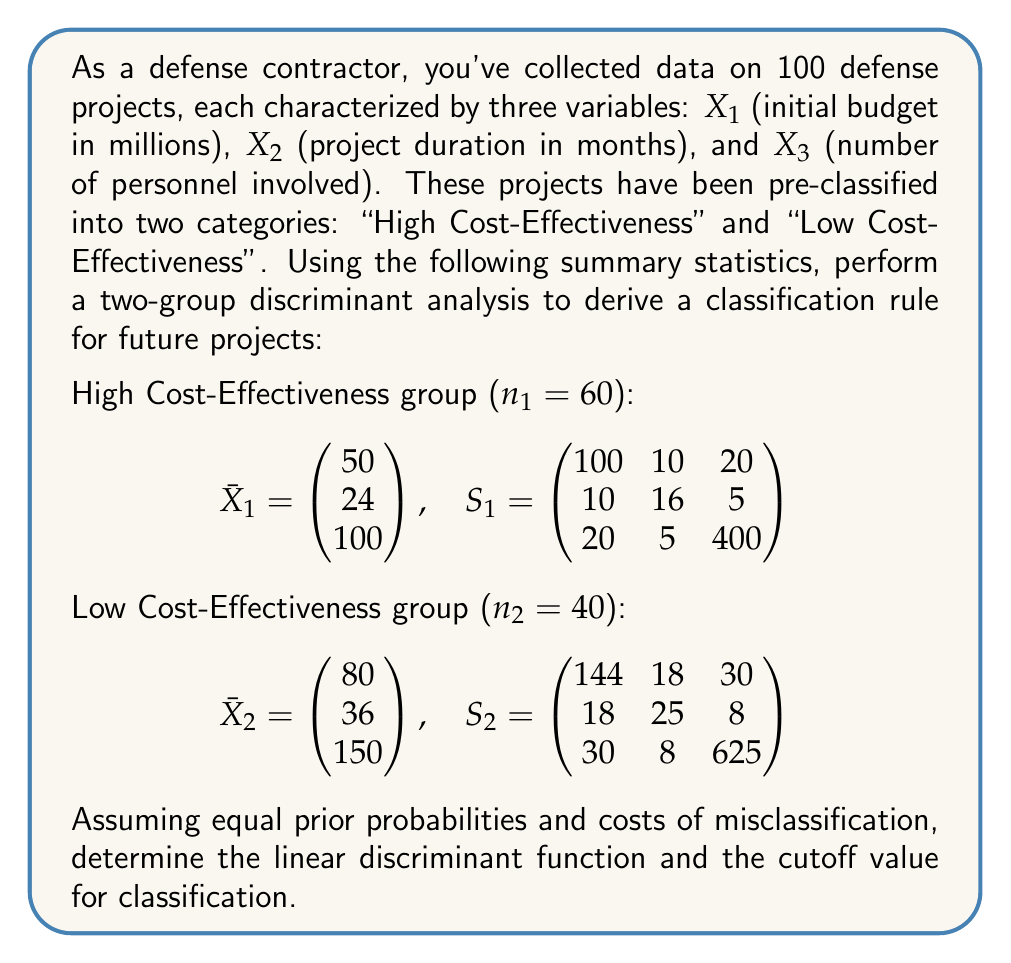Help me with this question. To perform a two-group discriminant analysis and derive a classification rule, we'll follow these steps:

1) Calculate the pooled covariance matrix:
   $$S_p = \frac{(n_1-1)S_1 + (n_2-1)S_2}{n_1+n_2-2}$$

   $$S_p = \frac{59\begin{pmatrix} 100 & 10 & 20 \\ 10 & 16 & 5 \\ 20 & 5 & 400 \end{pmatrix} + 39\begin{pmatrix} 144 & 18 & 30 \\ 18 & 25 & 8 \\ 30 & 8 & 625 \end{pmatrix}}{98}$$

   $$S_p = \begin{pmatrix} 117.8 & 13.2 & 24.0 \\ 13.2 & 19.6 & 6.2 \\ 24.0 & 6.2 & 490.3 \end{pmatrix}$$

2) Calculate the inverse of the pooled covariance matrix:
   $$S_p^{-1} = \begin{pmatrix} 0.00863 & -0.00571 & -0.00039 \\ -0.00571 & 0.05294 & -0.00052 \\ -0.00039 & -0.00052 & 0.00206 \end{pmatrix}$$

3) Calculate the difference between group means:
   $$\bar{X}_1 - \bar{X}_2 = \begin{pmatrix} -30 \\ -12 \\ -50 \end{pmatrix}$$

4) Calculate the linear discriminant function coefficients:
   $$a = S_p^{-1}(\bar{X}_1 - \bar{X}_2)$$
   
   $$a = \begin{pmatrix} 0.00863 & -0.00571 & -0.00039 \\ -0.00571 & 0.05294 & -0.00052 \\ -0.00039 & -0.00052 & 0.00206 \end{pmatrix} \begin{pmatrix} -30 \\ -12 \\ -50 \end{pmatrix}$$
   
   $$a = \begin{pmatrix} -0.3506 \\ -0.6961 \\ -0.1148 \end{pmatrix}$$

5) The linear discriminant function is:
   $$L = -0.3506X_1 - 0.6961X_2 - 0.1148X_3$$

6) Calculate the cutoff value:
   $$m = \frac{1}{2}a'(\bar{X}_1 + \bar{X}_2)$$
   
   $$m = \frac{1}{2}\begin{pmatrix} -0.3506 & -0.6961 & -0.1148 \end{pmatrix} \begin{pmatrix} 65 \\ 30 \\ 125 \end{pmatrix}$$
   
   $$m = -23.9725$$

The classification rule is:
- If $L < -23.9725$, classify as High Cost-Effectiveness
- If $L > -23.9725$, classify as Low Cost-Effectiveness
Answer: The linear discriminant function is $L = -0.3506X_1 - 0.6961X_2 - 0.1148X_3$, and the cutoff value is -23.9725. Classify a project as High Cost-Effectiveness if $L < -23.9725$, and as Low Cost-Effectiveness if $L > -23.9725$. 